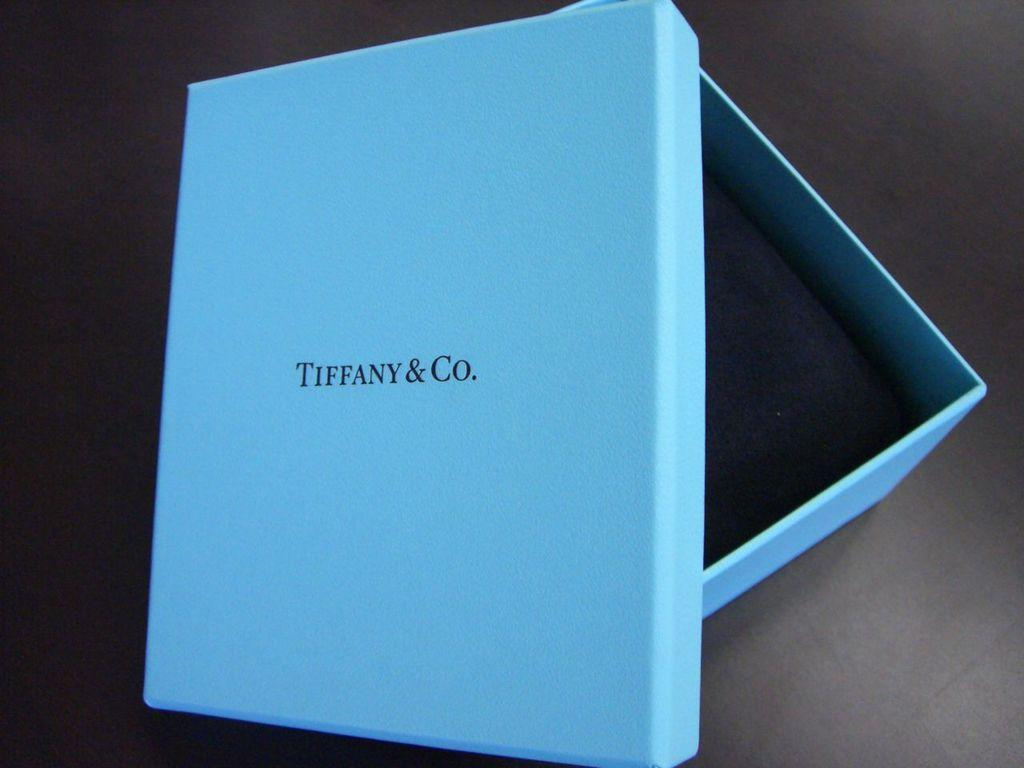Provide a one-sentence caption for the provided image. A blue box from Tiffany and Company sits on a black table. 